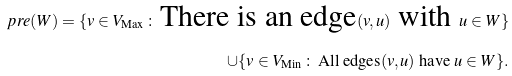Convert formula to latex. <formula><loc_0><loc_0><loc_500><loc_500>\ p r e ( W ) = \{ v \in V _ { \text {Max} } \, \colon \, \text {There is an edge} ( v , u ) \text { with } u \in W \} \\ \cup \{ v \in V _ { \text {Min} } \, \colon \, \text {All edges} ( v , u ) \text { have } u \in W \} .</formula> 